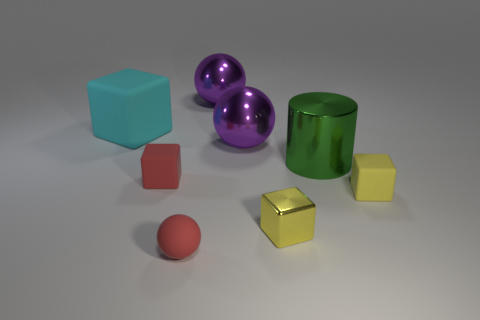Add 1 tiny red rubber cylinders. How many objects exist? 9 Subtract all cylinders. How many objects are left? 7 Subtract all purple rubber cylinders. Subtract all red spheres. How many objects are left? 7 Add 2 purple things. How many purple things are left? 4 Add 3 purple objects. How many purple objects exist? 5 Subtract 1 red blocks. How many objects are left? 7 